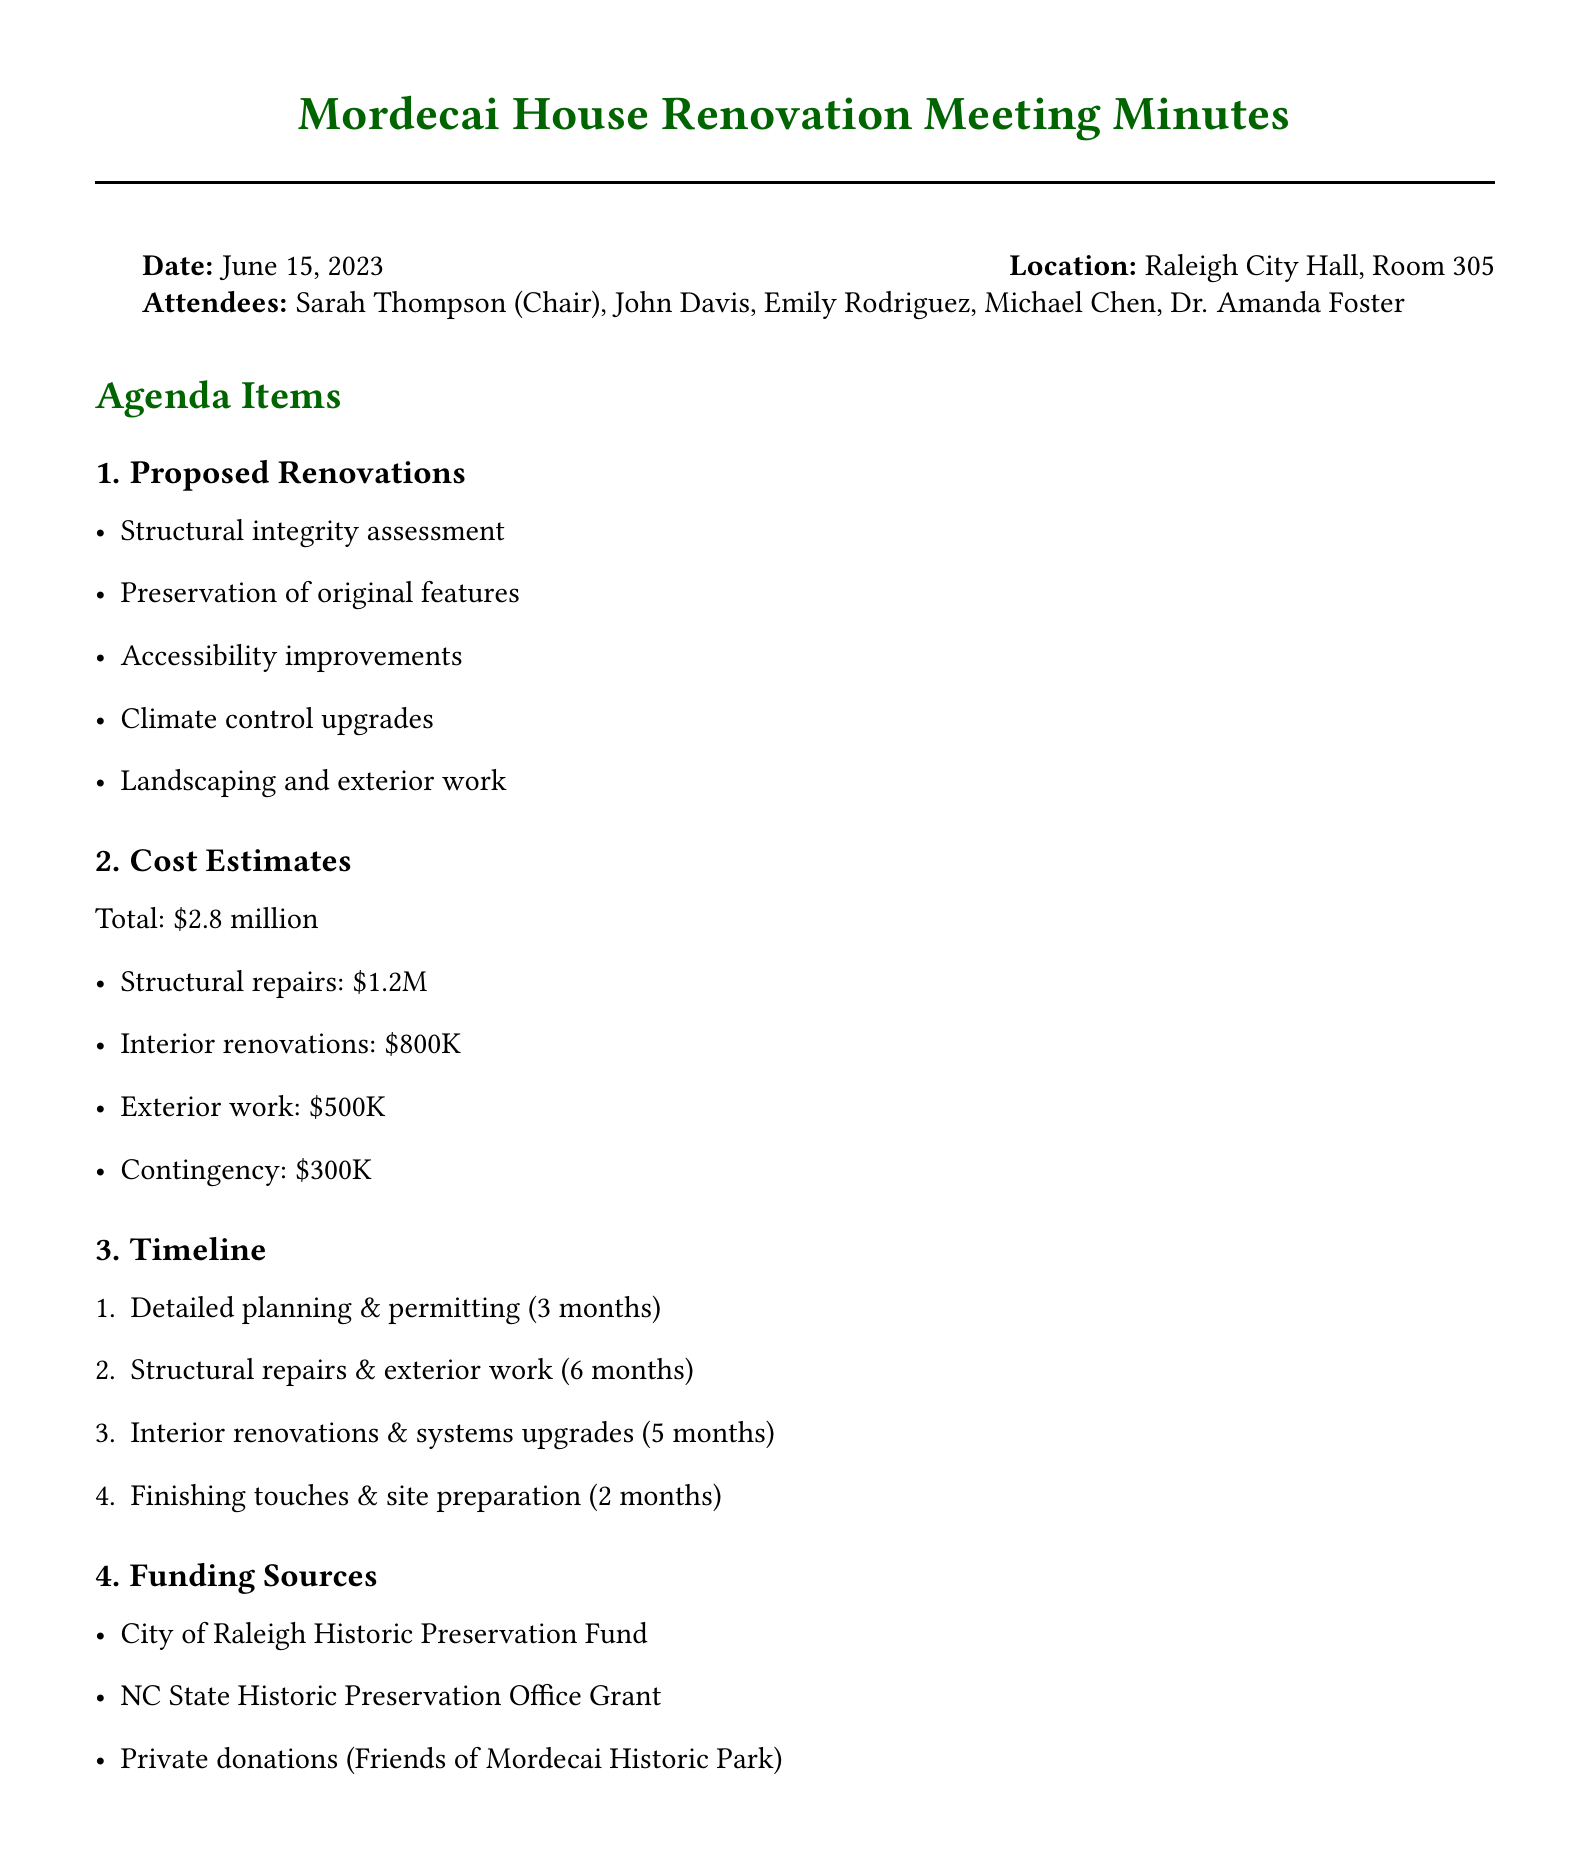What is the meeting date? The meeting date is explicitly stated in the document.
Answer: June 15, 2023 Who is the chair of the meeting? The document lists the attendees and identifies the chairperson.
Answer: Sarah Thompson What is the total estimated cost of renovations? The total cost is clearly mentioned in the cost estimates section.
Answer: $2.8 million How many months are allocated for detailed planning and permitting? The timeline itemizes the phases with specific durations for each.
Answer: 3 months What funding source is mentioned for private donations? The document specifies a group associated with private donations.
Answer: Friends of Mordecai Historic Park What concern relates to balancing modern requirements and historical authenticity? The document lists concerns raised during the meeting, specifying this particular issue.
Answer: Balancing modern accessibility requirements with historical authenticity How many months will structural repairs and exterior work take? The timeline includes the duration for this specific phase of the project.
Answer: 6 months What is the first action item listed in the document? The action items are explicitly listed, and the first item is identifiable.
Answer: Schedule follow-up meeting to review detailed architectural plans 